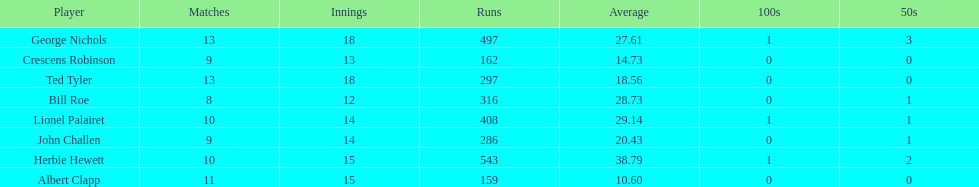How many runs did ted tyler have? 297. 